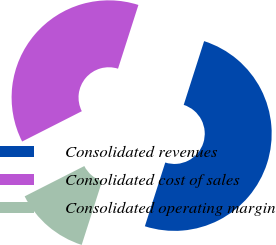Convert chart. <chart><loc_0><loc_0><loc_500><loc_500><pie_chart><fcel>Consolidated revenues<fcel>Consolidated cost of sales<fcel>Consolidated operating margin<nl><fcel>50.0%<fcel>37.41%<fcel>12.59%<nl></chart> 